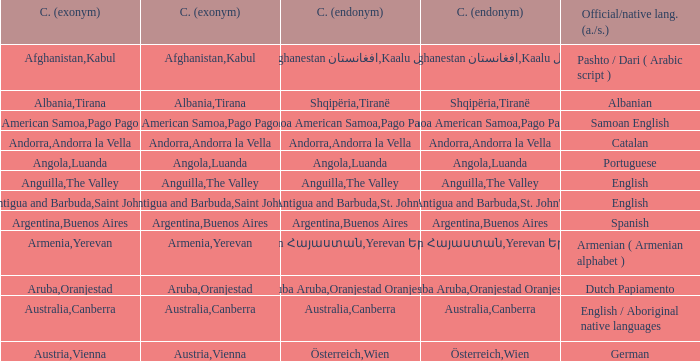What is the local name given to the city of Canberra? Canberra. 